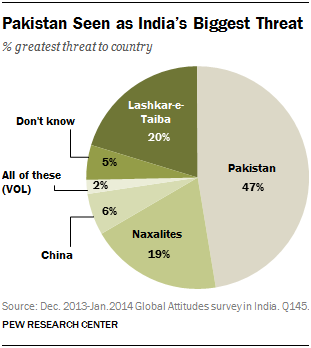Specify some key components in this picture. According to a recent survey, 47% of people perceive Pakistan as the greatest threat to India. 